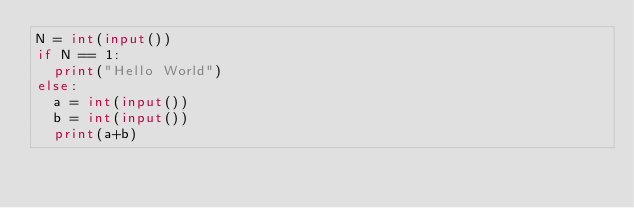Convert code to text. <code><loc_0><loc_0><loc_500><loc_500><_Python_>N = int(input())
if N == 1:
  print("Hello World")
else:
  a = int(input())
  b = int(input())
  print(a+b)</code> 